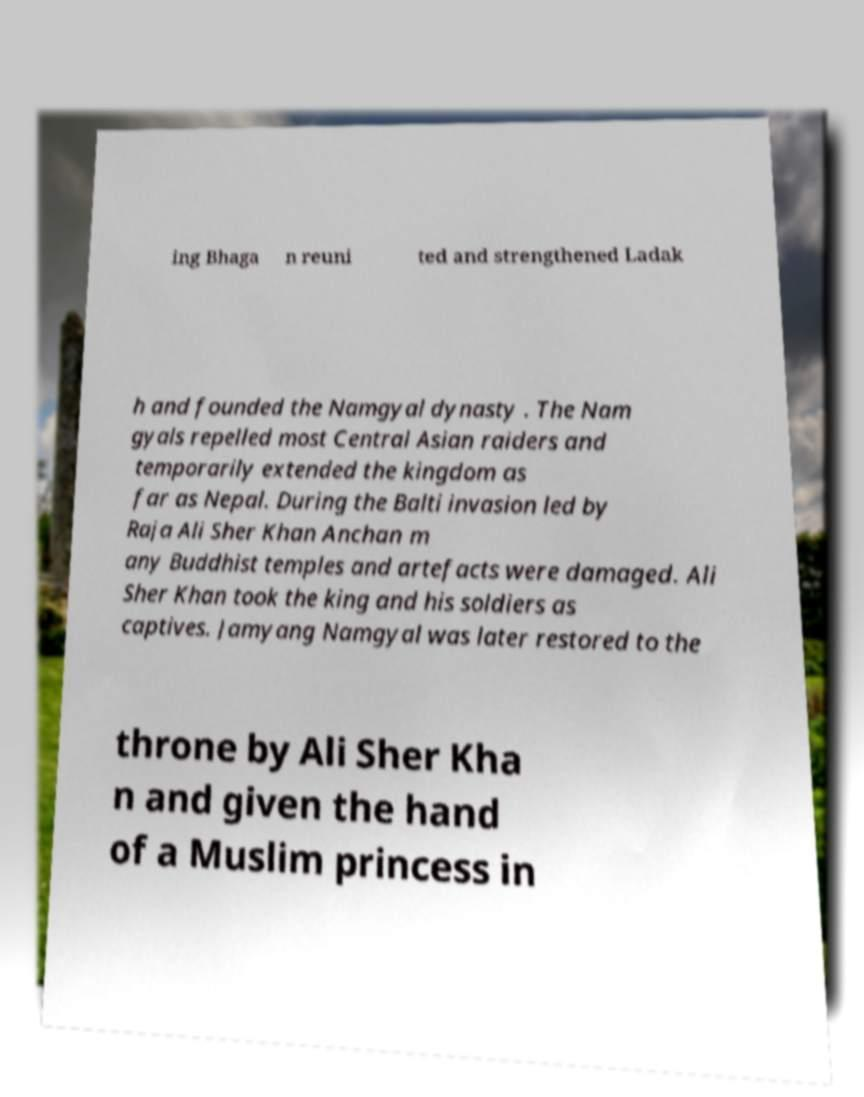Please read and relay the text visible in this image. What does it say? ing Bhaga n reuni ted and strengthened Ladak h and founded the Namgyal dynasty . The Nam gyals repelled most Central Asian raiders and temporarily extended the kingdom as far as Nepal. During the Balti invasion led by Raja Ali Sher Khan Anchan m any Buddhist temples and artefacts were damaged. Ali Sher Khan took the king and his soldiers as captives. Jamyang Namgyal was later restored to the throne by Ali Sher Kha n and given the hand of a Muslim princess in 